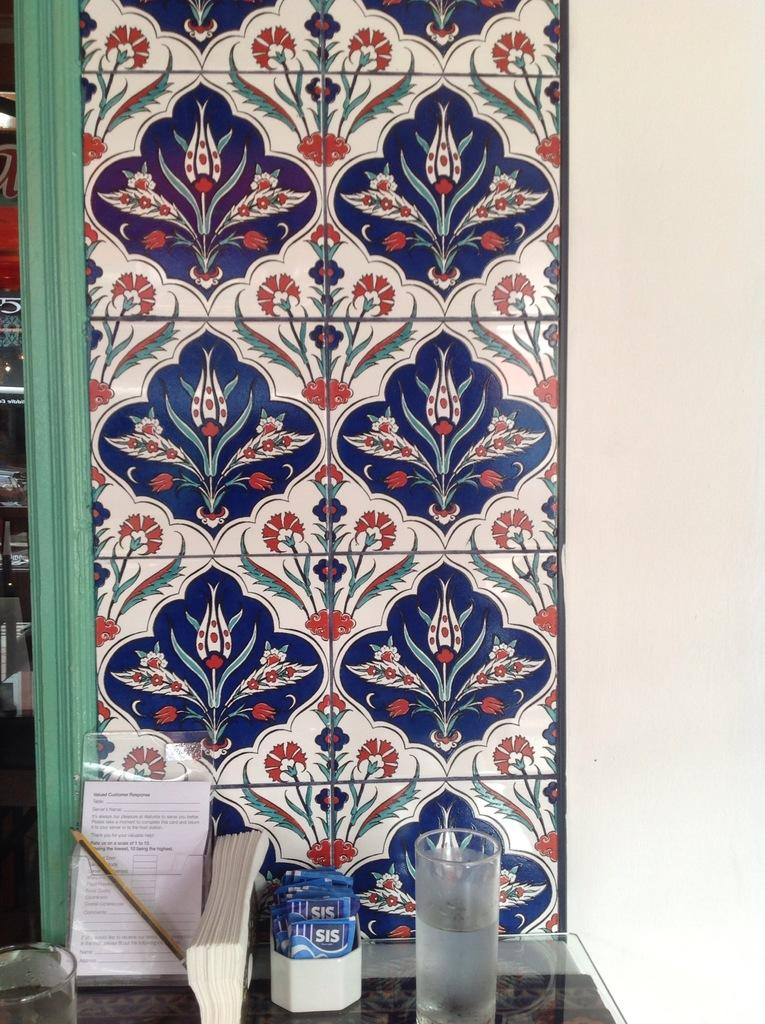What piece of furniture is present at the bottom of the image? There is a table at the bottom of the image. What items can be seen on the table? There is a glass, a tissue holder, a paper, and a pencil on the table. What is the pattern on the wall behind the table? The wall has a flower pattern. What type of game is being played on the table in the image? There is no game being played on the table in the image. How many snakes are visible on the table in the image? There are no snakes present on the table in the image. 